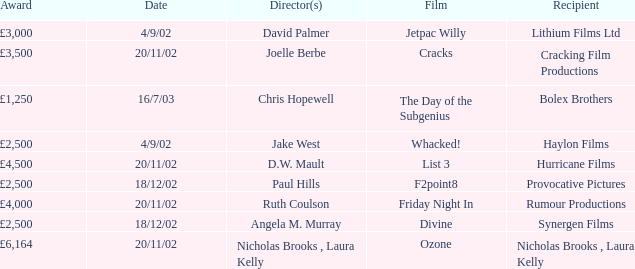Who was awarded £3,000 on 4/9/02? Lithium Films Ltd. 